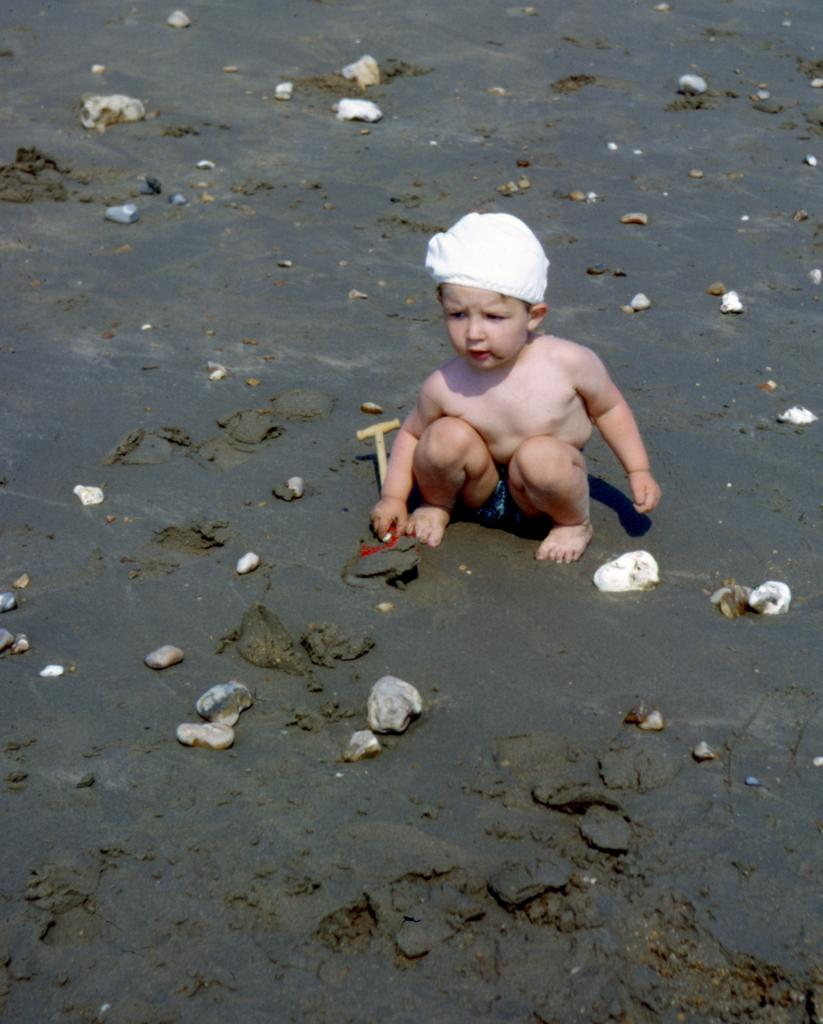Who is present in the image? There is a boy in the image. What is the boy standing on? A: The boy is on the sand. What other objects can be seen in the image? There are stones in the image. What type of growth can be seen on the hall in the image? There is no hall present in the image, and therefore no growth can be observed. 